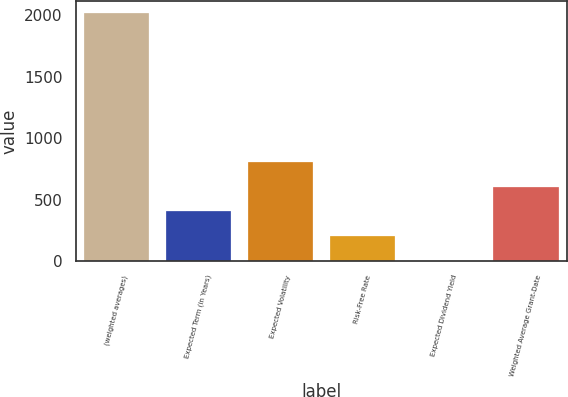<chart> <loc_0><loc_0><loc_500><loc_500><bar_chart><fcel>(weighted averages)<fcel>Expected Term (in Years)<fcel>Expected Volatility<fcel>Risk-Free Rate<fcel>Expected Dividend Yield<fcel>Weighted Average Grant-Date<nl><fcel>2016<fcel>403.76<fcel>806.82<fcel>202.23<fcel>0.7<fcel>605.29<nl></chart> 